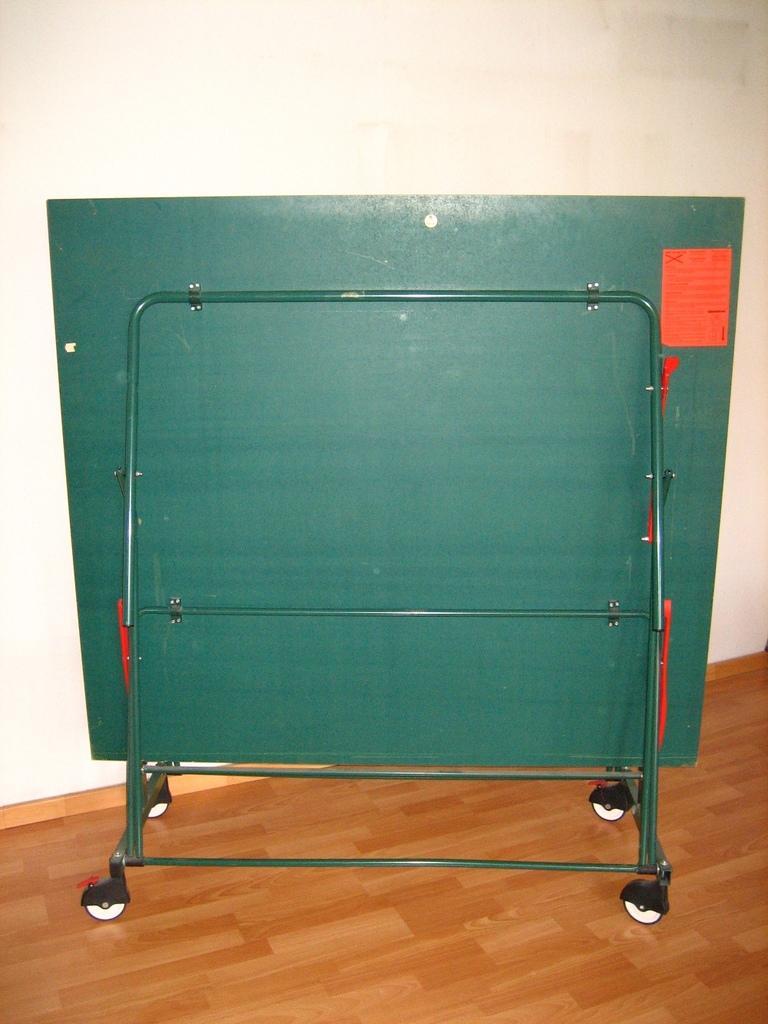Could you give a brief overview of what you see in this image? This image is taken outdoors. At the bottom of the image there is a floor. In the background there is a wall. In the middle of the image there is a board on the stand. 